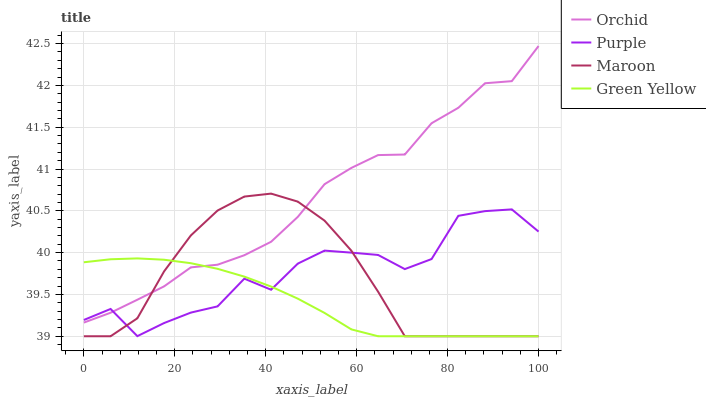Does Green Yellow have the minimum area under the curve?
Answer yes or no. Yes. Does Orchid have the maximum area under the curve?
Answer yes or no. Yes. Does Maroon have the minimum area under the curve?
Answer yes or no. No. Does Maroon have the maximum area under the curve?
Answer yes or no. No. Is Green Yellow the smoothest?
Answer yes or no. Yes. Is Purple the roughest?
Answer yes or no. Yes. Is Maroon the smoothest?
Answer yes or no. No. Is Maroon the roughest?
Answer yes or no. No. Does Green Yellow have the lowest value?
Answer yes or no. Yes. Does Orchid have the lowest value?
Answer yes or no. No. Does Orchid have the highest value?
Answer yes or no. Yes. Does Maroon have the highest value?
Answer yes or no. No. Does Purple intersect Orchid?
Answer yes or no. Yes. Is Purple less than Orchid?
Answer yes or no. No. Is Purple greater than Orchid?
Answer yes or no. No. 